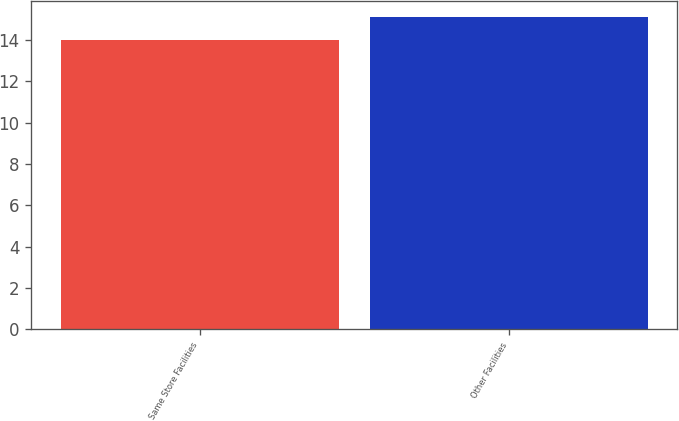Convert chart to OTSL. <chart><loc_0><loc_0><loc_500><loc_500><bar_chart><fcel>Same Store Facilities<fcel>Other Facilities<nl><fcel>14.02<fcel>15.14<nl></chart> 